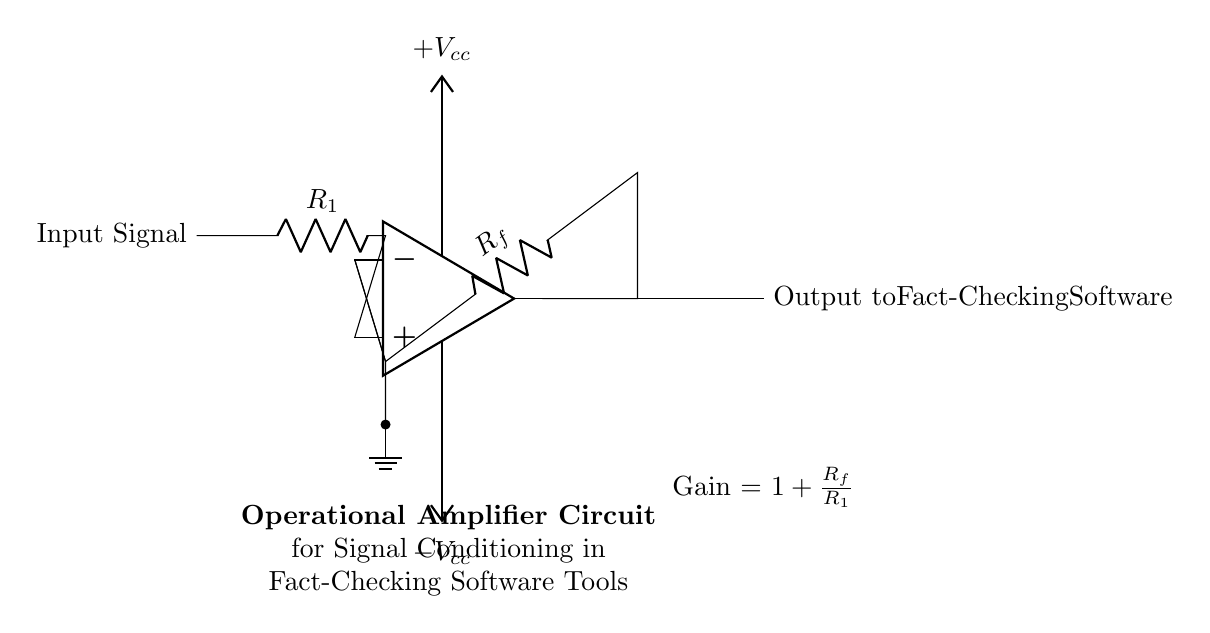What type of amplifier is represented in this circuit? The circuit illustrates an operational amplifier, which is an essential component in analog electronic circuits used for various signal processing tasks. The symbol shown directly indicates it is an op-amp.
Answer: operational amplifier What is the function of the resistor labeled R1? Resistor R1 is connected to the input signal and plays a vital role in determining the input impedance of the amplifier and directly affects the gain of the circuit when paired with the feedback resistor.
Answer: input impedance What does the gain equation for this circuit indicate? The gain equation, Gain = 1 + Rf/R1, indicates how the output voltage will be amplified in relation to the input voltage based on the values of the resistors Rf and R1, impacting the signal conditioning for the output to the fact-checking software.
Answer: Gain = 1 + Rf/R1 What are the supply voltages connected to this op-amp? The operational amplifier requires dual supply voltages labeled as +Vcc and -Vcc, which provide the necessary operating conditions for linear amplification and signal processing within the circuit.
Answer: +Vcc and -Vcc What is the output intended for in this circuit? The output from the operational amplifier is specifically designated for use in fact-checking software, indicating its role in enhancing or conditioning signals for further processing in software tools aimed at verifying information.
Answer: Output to Fact-Checking Software How is the feedback for the op-amp configured in this circuit? The circuit shows a feedback arrangement from the output back to the inverting input through the resistor Rf, creating a closed-loop system that stabilizes and controls the gain of the amplifier for linear operations.
Answer: negative feedback 